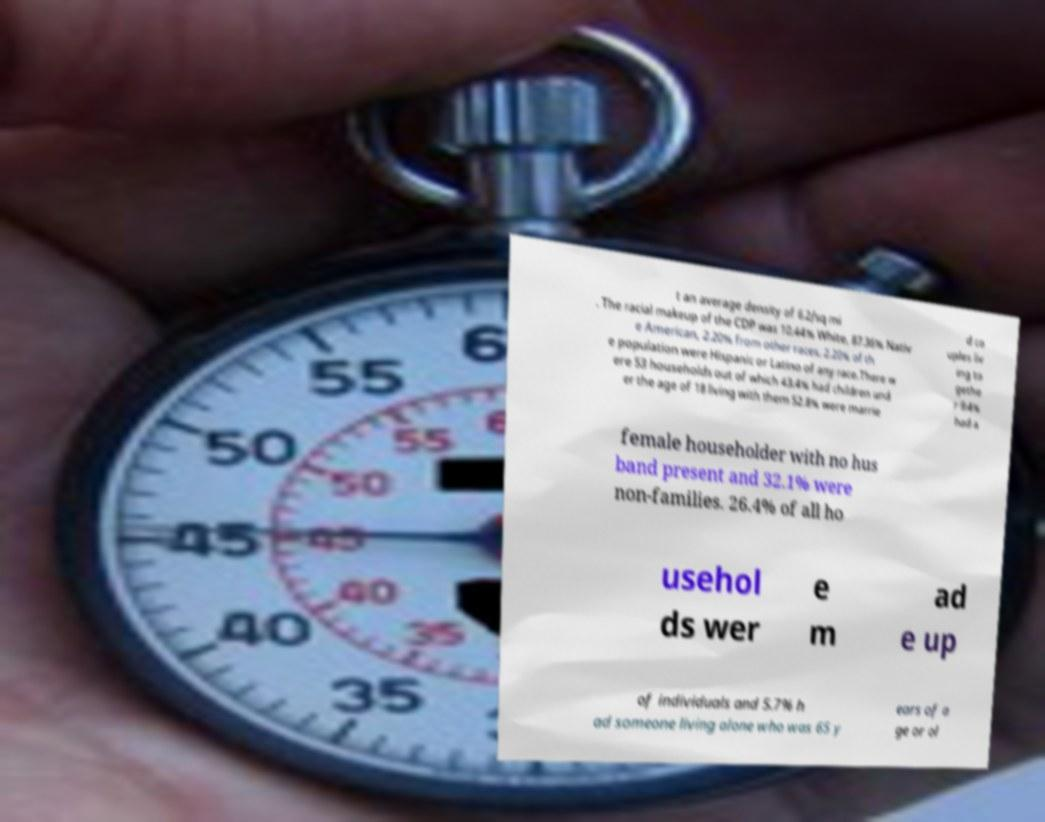Can you read and provide the text displayed in the image?This photo seems to have some interesting text. Can you extract and type it out for me? t an average density of 6.2/sq mi . The racial makeup of the CDP was 10.44% White, 87.36% Nativ e American, 2.20% from other races. 2.20% of th e population were Hispanic or Latino of any race.There w ere 53 households out of which 43.4% had children und er the age of 18 living with them 52.8% were marrie d co uples liv ing to gethe r 9.4% had a female householder with no hus band present and 32.1% were non-families. 26.4% of all ho usehol ds wer e m ad e up of individuals and 5.7% h ad someone living alone who was 65 y ears of a ge or ol 